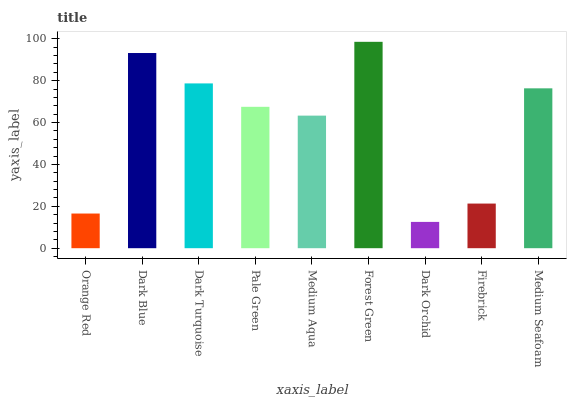Is Dark Orchid the minimum?
Answer yes or no. Yes. Is Forest Green the maximum?
Answer yes or no. Yes. Is Dark Blue the minimum?
Answer yes or no. No. Is Dark Blue the maximum?
Answer yes or no. No. Is Dark Blue greater than Orange Red?
Answer yes or no. Yes. Is Orange Red less than Dark Blue?
Answer yes or no. Yes. Is Orange Red greater than Dark Blue?
Answer yes or no. No. Is Dark Blue less than Orange Red?
Answer yes or no. No. Is Pale Green the high median?
Answer yes or no. Yes. Is Pale Green the low median?
Answer yes or no. Yes. Is Medium Seafoam the high median?
Answer yes or no. No. Is Medium Aqua the low median?
Answer yes or no. No. 